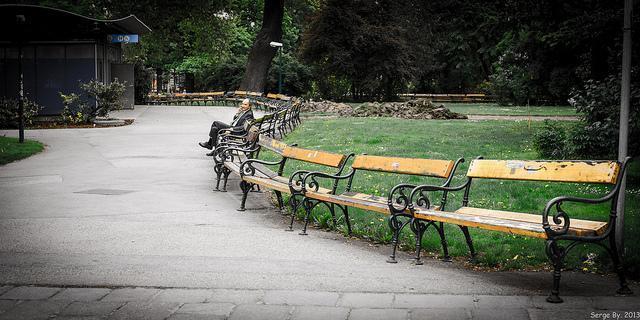How many benches are visible?
Give a very brief answer. 3. How many tracks have a train on them?
Give a very brief answer. 0. 